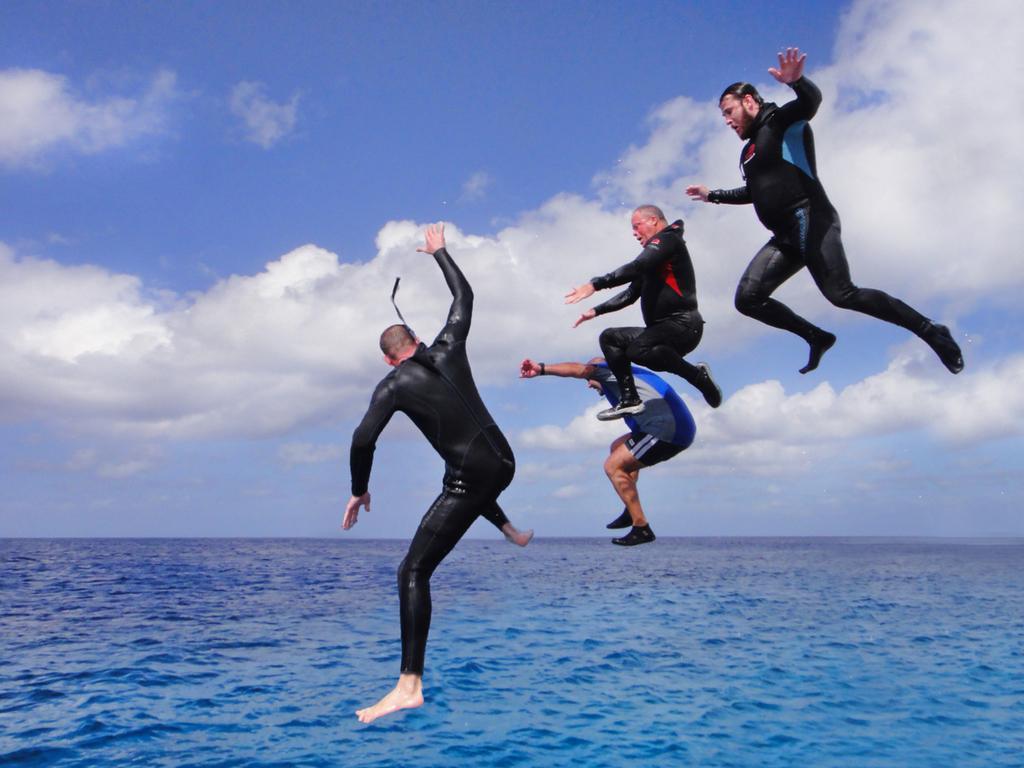Can you describe this image briefly? In this image I can see four men wearing black color dresses and jumping into the water. This is looking like an Ocean. At the top I can see the sky and clouds. 